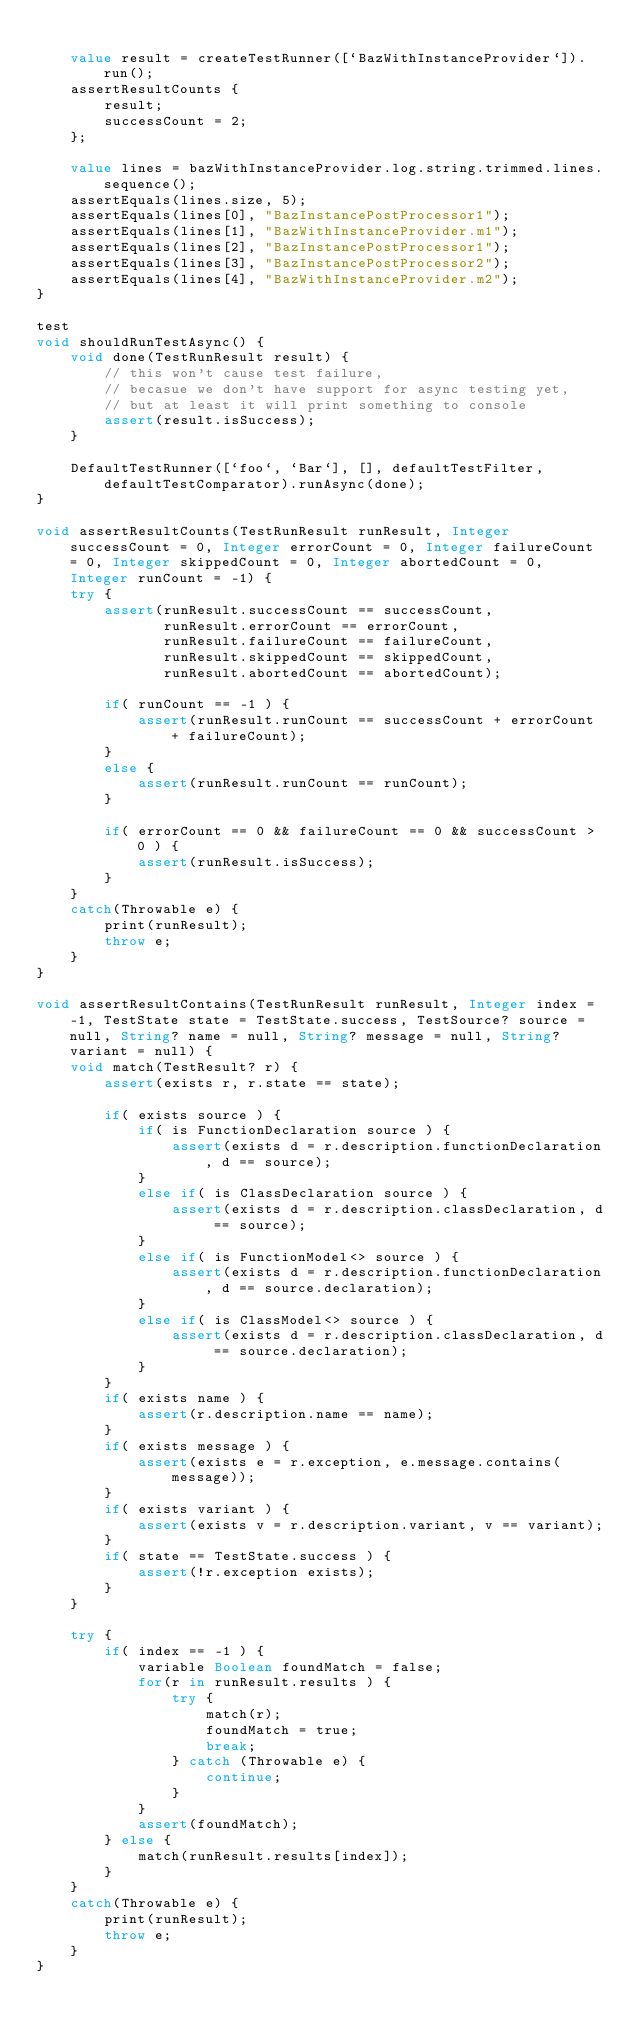Convert code to text. <code><loc_0><loc_0><loc_500><loc_500><_Ceylon_>    
    value result = createTestRunner([`BazWithInstanceProvider`]).run();
    assertResultCounts {
        result;
        successCount = 2;
    };
    
    value lines = bazWithInstanceProvider.log.string.trimmed.lines.sequence();
    assertEquals(lines.size, 5);
    assertEquals(lines[0], "BazInstancePostProcessor1");
    assertEquals(lines[1], "BazWithInstanceProvider.m1");
    assertEquals(lines[2], "BazInstancePostProcessor1");
    assertEquals(lines[3], "BazInstancePostProcessor2");
    assertEquals(lines[4], "BazWithInstanceProvider.m2");
}

test
void shouldRunTestAsync() {
    void done(TestRunResult result) {
        // this won't cause test failure, 
        // becasue we don't have support for async testing yet, 
        // but at least it will print something to console
        assert(result.isSuccess);
    }
    
    DefaultTestRunner([`foo`, `Bar`], [], defaultTestFilter, defaultTestComparator).runAsync(done);
}

void assertResultCounts(TestRunResult runResult, Integer successCount = 0, Integer errorCount = 0, Integer failureCount = 0, Integer skippedCount = 0, Integer abortedCount = 0, Integer runCount = -1) {
    try {
        assert(runResult.successCount == successCount, 
               runResult.errorCount == errorCount, 
               runResult.failureCount == failureCount, 
               runResult.skippedCount == skippedCount,
               runResult.abortedCount == abortedCount);
        
        if( runCount == -1 ) {
            assert(runResult.runCount == successCount + errorCount + failureCount);
        }
        else {
            assert(runResult.runCount == runCount);
        }
        
        if( errorCount == 0 && failureCount == 0 && successCount > 0 ) {
            assert(runResult.isSuccess);
        }
    }
    catch(Throwable e) {
        print(runResult);
        throw e;
    }
}

void assertResultContains(TestRunResult runResult, Integer index = -1, TestState state = TestState.success, TestSource? source = null, String? name = null, String? message = null, String? variant = null) {
    void match(TestResult? r) {
        assert(exists r, r.state == state);
        
        if( exists source ) {
            if( is FunctionDeclaration source ) {
                assert(exists d = r.description.functionDeclaration, d == source);
            }
            else if( is ClassDeclaration source ) {
                assert(exists d = r.description.classDeclaration, d == source);
            }
            else if( is FunctionModel<> source ) {
                assert(exists d = r.description.functionDeclaration, d == source.declaration);
            }
            else if( is ClassModel<> source ) {
                assert(exists d = r.description.classDeclaration, d == source.declaration);
            }
        }
        if( exists name ) {
            assert(r.description.name == name);
        }
        if( exists message ) {
            assert(exists e = r.exception, e.message.contains(message));
        }
        if( exists variant ) {
            assert(exists v = r.description.variant, v == variant);
        }
        if( state == TestState.success ) {
            assert(!r.exception exists);
        }
    }
    
    try {
        if( index == -1 ) {
            variable Boolean foundMatch = false;
            for(r in runResult.results ) {
                try {
                    match(r);
                    foundMatch = true;
                    break;
                } catch (Throwable e) {
                    continue;
                }
            }
            assert(foundMatch);
        } else {
            match(runResult.results[index]);
        }
    }
    catch(Throwable e) {
        print(runResult);
        throw e;
    }
}
</code> 